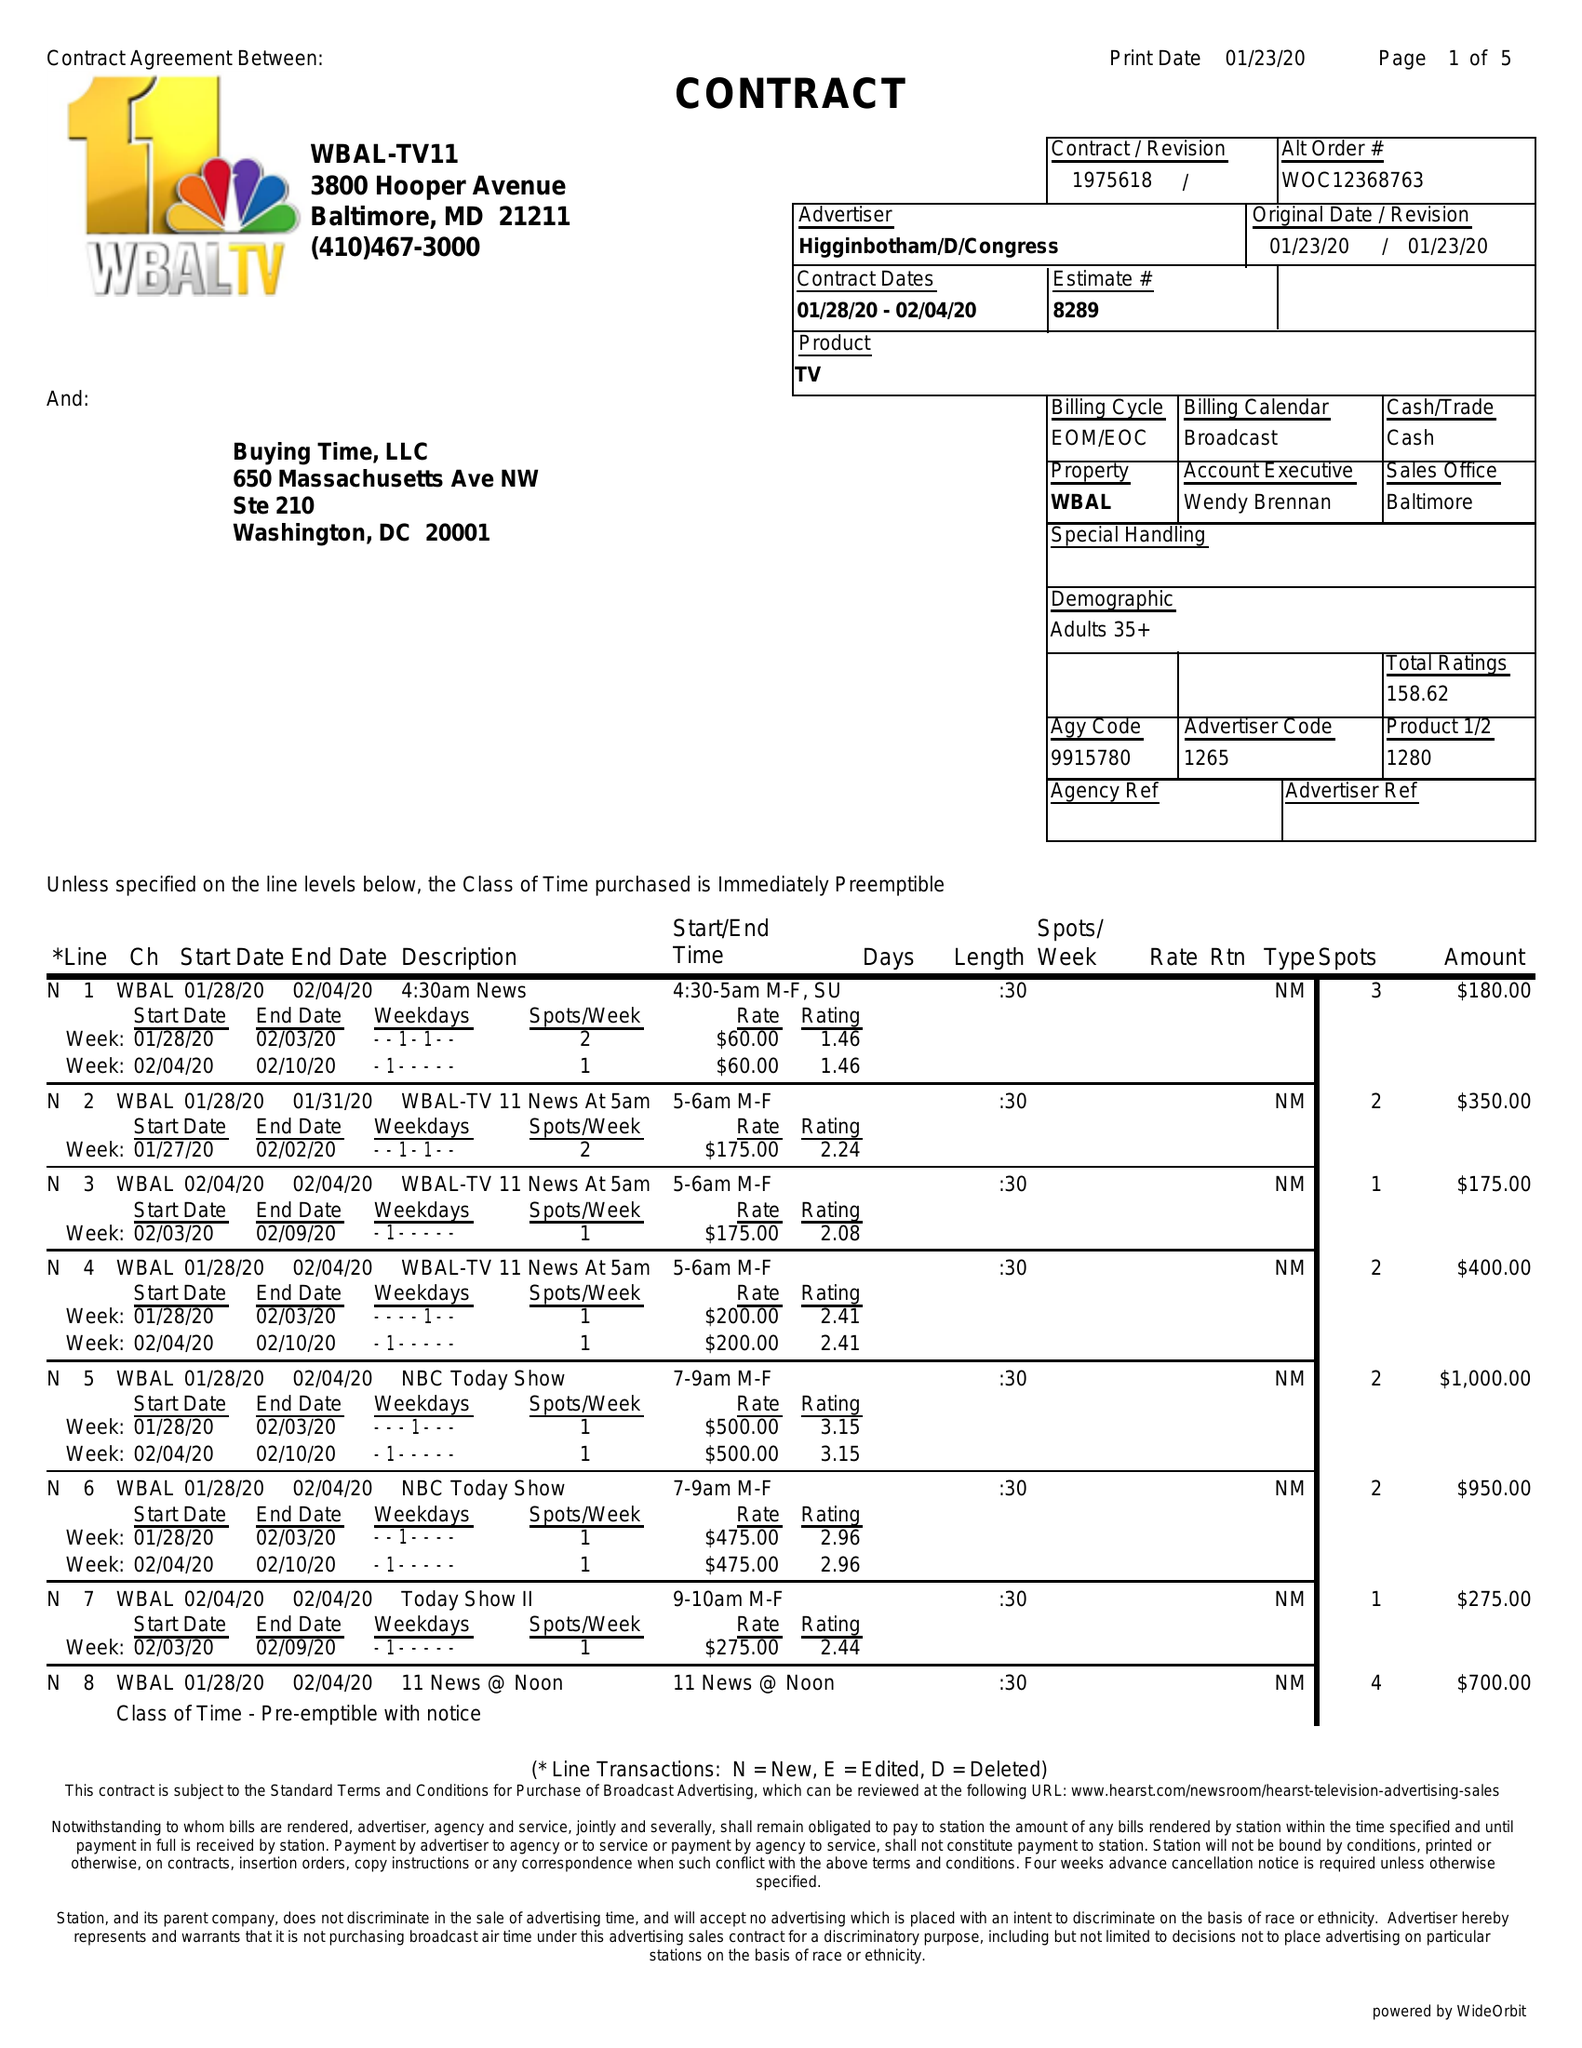What is the value for the contract_num?
Answer the question using a single word or phrase. 1975618 